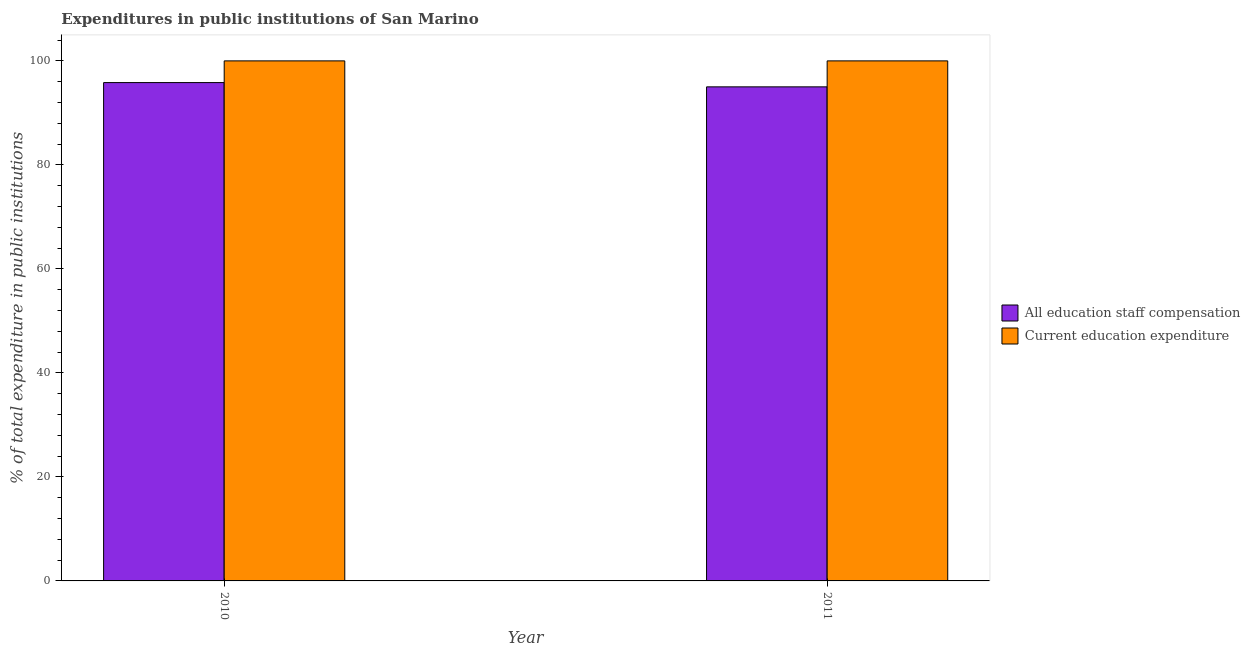How many different coloured bars are there?
Offer a terse response. 2. Are the number of bars on each tick of the X-axis equal?
Provide a short and direct response. Yes. How many bars are there on the 2nd tick from the left?
Your response must be concise. 2. What is the label of the 2nd group of bars from the left?
Give a very brief answer. 2011. What is the expenditure in staff compensation in 2010?
Provide a succinct answer. 95.83. Across all years, what is the maximum expenditure in staff compensation?
Offer a very short reply. 95.83. Across all years, what is the minimum expenditure in education?
Your answer should be very brief. 100. In which year was the expenditure in education minimum?
Give a very brief answer. 2010. What is the total expenditure in staff compensation in the graph?
Give a very brief answer. 190.83. What is the difference between the expenditure in education in 2010 and that in 2011?
Ensure brevity in your answer.  0. What is the difference between the expenditure in education in 2011 and the expenditure in staff compensation in 2010?
Keep it short and to the point. 0. What is the average expenditure in staff compensation per year?
Your answer should be compact. 95.42. Is the expenditure in staff compensation in 2010 less than that in 2011?
Your answer should be compact. No. What does the 1st bar from the left in 2011 represents?
Provide a succinct answer. All education staff compensation. What does the 2nd bar from the right in 2010 represents?
Your response must be concise. All education staff compensation. How many years are there in the graph?
Offer a terse response. 2. Are the values on the major ticks of Y-axis written in scientific E-notation?
Your answer should be very brief. No. Does the graph contain any zero values?
Provide a succinct answer. No. Does the graph contain grids?
Give a very brief answer. No. How are the legend labels stacked?
Your answer should be compact. Vertical. What is the title of the graph?
Ensure brevity in your answer.  Expenditures in public institutions of San Marino. What is the label or title of the X-axis?
Your answer should be very brief. Year. What is the label or title of the Y-axis?
Provide a short and direct response. % of total expenditure in public institutions. What is the % of total expenditure in public institutions in All education staff compensation in 2010?
Keep it short and to the point. 95.83. What is the % of total expenditure in public institutions in Current education expenditure in 2010?
Offer a terse response. 100. What is the % of total expenditure in public institutions in All education staff compensation in 2011?
Offer a very short reply. 95.01. Across all years, what is the maximum % of total expenditure in public institutions of All education staff compensation?
Ensure brevity in your answer.  95.83. Across all years, what is the maximum % of total expenditure in public institutions of Current education expenditure?
Offer a very short reply. 100. Across all years, what is the minimum % of total expenditure in public institutions in All education staff compensation?
Your answer should be very brief. 95.01. Across all years, what is the minimum % of total expenditure in public institutions of Current education expenditure?
Provide a short and direct response. 100. What is the total % of total expenditure in public institutions of All education staff compensation in the graph?
Give a very brief answer. 190.83. What is the total % of total expenditure in public institutions in Current education expenditure in the graph?
Your answer should be compact. 200. What is the difference between the % of total expenditure in public institutions of All education staff compensation in 2010 and that in 2011?
Your response must be concise. 0.82. What is the difference between the % of total expenditure in public institutions in Current education expenditure in 2010 and that in 2011?
Your response must be concise. 0. What is the difference between the % of total expenditure in public institutions in All education staff compensation in 2010 and the % of total expenditure in public institutions in Current education expenditure in 2011?
Make the answer very short. -4.17. What is the average % of total expenditure in public institutions of All education staff compensation per year?
Offer a very short reply. 95.42. In the year 2010, what is the difference between the % of total expenditure in public institutions of All education staff compensation and % of total expenditure in public institutions of Current education expenditure?
Offer a very short reply. -4.17. In the year 2011, what is the difference between the % of total expenditure in public institutions of All education staff compensation and % of total expenditure in public institutions of Current education expenditure?
Make the answer very short. -4.99. What is the ratio of the % of total expenditure in public institutions of All education staff compensation in 2010 to that in 2011?
Provide a short and direct response. 1.01. What is the difference between the highest and the second highest % of total expenditure in public institutions of All education staff compensation?
Ensure brevity in your answer.  0.82. What is the difference between the highest and the second highest % of total expenditure in public institutions of Current education expenditure?
Provide a succinct answer. 0. What is the difference between the highest and the lowest % of total expenditure in public institutions in All education staff compensation?
Provide a short and direct response. 0.82. 